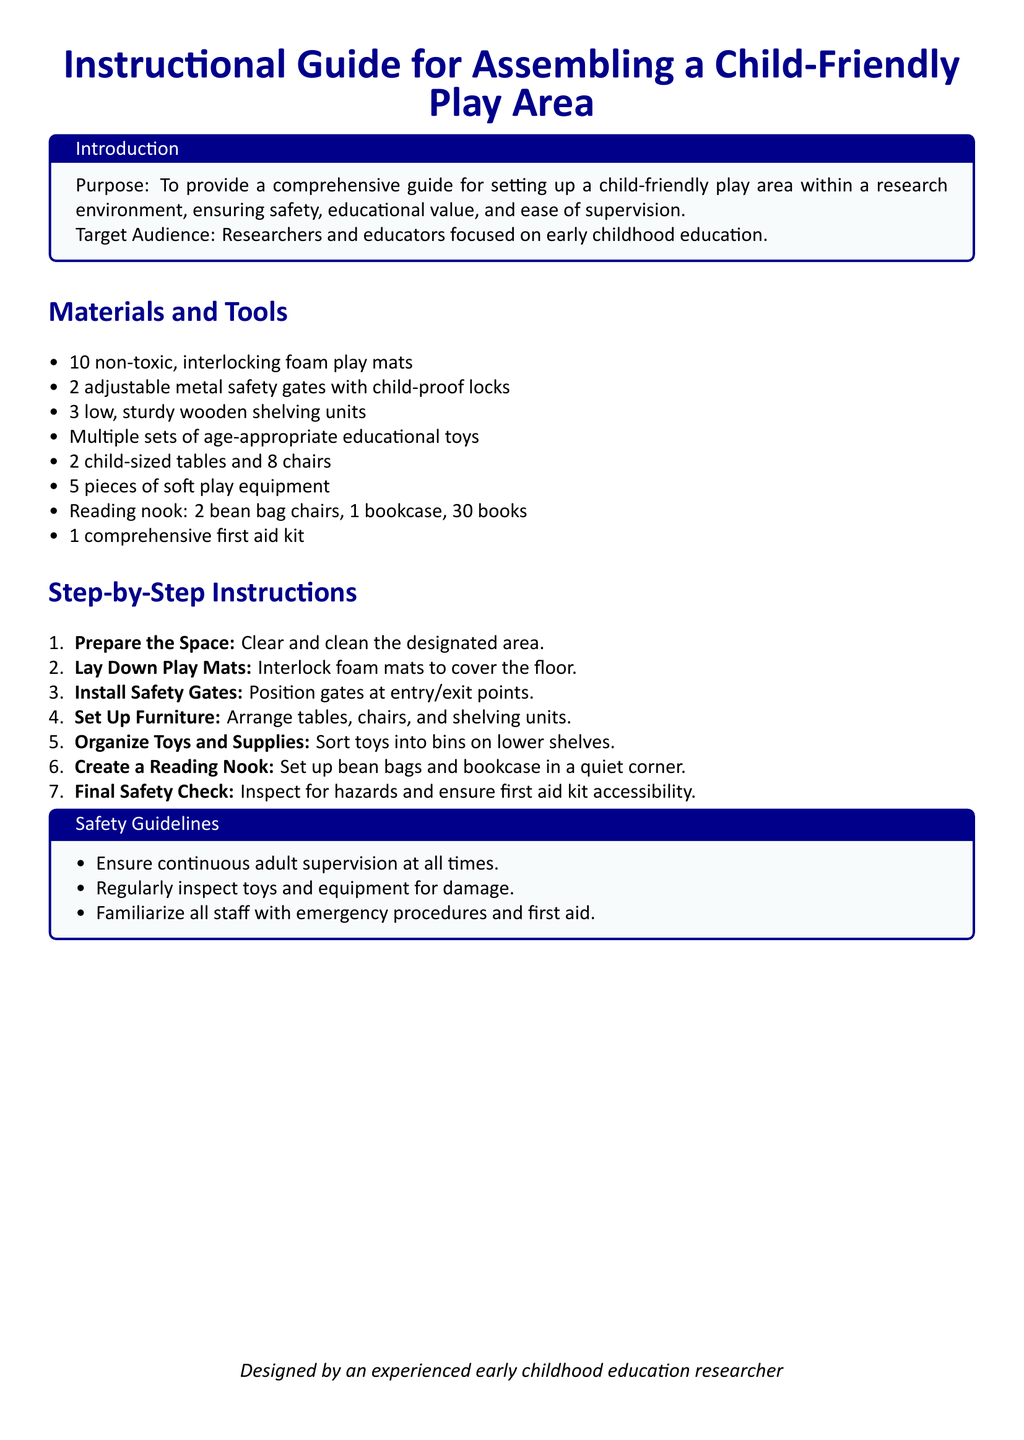What is the purpose of the guide? The purpose of the guide is to provide a comprehensive guide for setting up a child-friendly play area within a research environment, ensuring safety, educational value, and ease of supervision.
Answer: To provide a comprehensive guide for setting up a child-friendly play area How many play mats are required? The document specifies a total count of materials needed, indicating that 10 non-toxic, interlocking foam play mats are required.
Answer: 10 What type of furniture is included? The guide lists several furniture items needed for the play area, which includes 2 child-sized tables and 8 chairs.
Answer: 2 child-sized tables and 8 chairs What equipment is necessary for safety? Safety guidelines mention that a comprehensive first aid kit is necessary, which is crucial for addressing emergencies.
Answer: A comprehensive first aid kit How many steps are included in the assembly instructions? By counting the steps outlined in the step-by-step section, we find that there are a total of 7 steps involved in assembling the play area.
Answer: 7 What is the last step in the instructions? The final step in the assembly instructions focuses on ensuring a final safety check to inspect for hazards and accessibility of the first aid kit.
Answer: Final Safety Check Who is the document designed by? The document concludes with a note on its authorship, clearly stating that it is designed by an experienced early childhood education researcher.
Answer: An experienced early childhood education researcher 